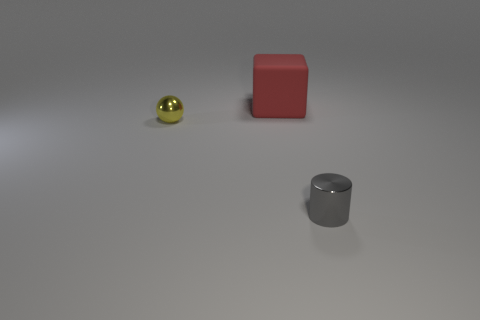Add 2 small yellow objects. How many objects exist? 5 Subtract all spheres. How many objects are left? 2 Subtract all green balls. How many yellow cylinders are left? 0 Subtract all blocks. Subtract all yellow objects. How many objects are left? 1 Add 3 big red matte things. How many big red matte things are left? 4 Add 1 big purple cylinders. How many big purple cylinders exist? 1 Subtract 0 brown cubes. How many objects are left? 3 Subtract all blue cubes. Subtract all red cylinders. How many cubes are left? 1 